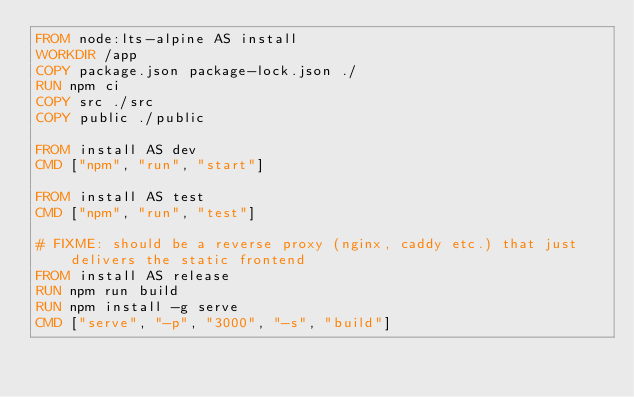<code> <loc_0><loc_0><loc_500><loc_500><_Dockerfile_>FROM node:lts-alpine AS install
WORKDIR /app
COPY package.json package-lock.json ./
RUN npm ci
COPY src ./src
COPY public ./public

FROM install AS dev
CMD ["npm", "run", "start"]

FROM install AS test
CMD ["npm", "run", "test"]

# FIXME: should be a reverse proxy (nginx, caddy etc.) that just delivers the static frontend
FROM install AS release
RUN npm run build
RUN npm install -g serve
CMD ["serve", "-p", "3000", "-s", "build"]</code> 